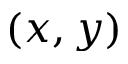Convert formula to latex. <formula><loc_0><loc_0><loc_500><loc_500>( x , y )</formula> 